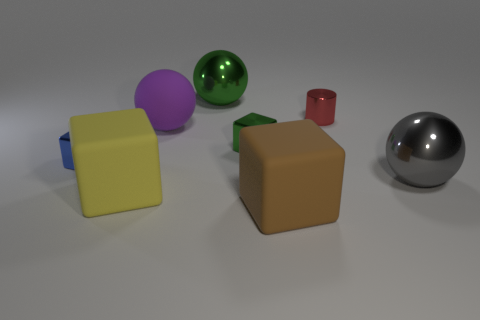There is a tiny thing that is on the right side of the blue object and on the left side of the tiny red metallic object; what material is it?
Keep it short and to the point. Metal. What number of metal objects are spheres or small cyan cylinders?
Provide a succinct answer. 2. There is a small blue object that is the same material as the small cylinder; what is its shape?
Make the answer very short. Cube. What number of big objects are on the left side of the gray thing and in front of the purple object?
Provide a succinct answer. 2. Is there anything else that is the same shape as the brown thing?
Give a very brief answer. Yes. What size is the ball that is behind the red cylinder?
Give a very brief answer. Large. How many other things are there of the same color as the cylinder?
Provide a succinct answer. 0. What is the material of the block in front of the big cube that is left of the brown matte cube?
Offer a very short reply. Rubber. How many small blue things are the same shape as the large purple object?
Keep it short and to the point. 0. What is the size of the gray object that is the same material as the green cube?
Ensure brevity in your answer.  Large. 